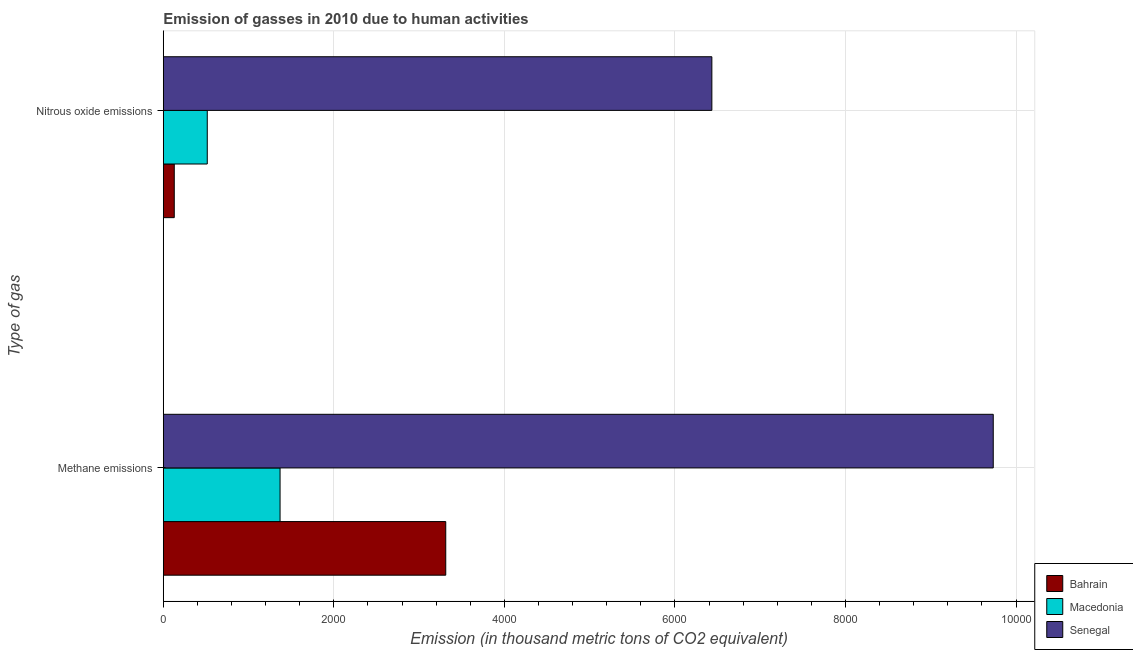How many different coloured bars are there?
Your answer should be compact. 3. How many groups of bars are there?
Your response must be concise. 2. Are the number of bars per tick equal to the number of legend labels?
Make the answer very short. Yes. How many bars are there on the 2nd tick from the bottom?
Provide a succinct answer. 3. What is the label of the 1st group of bars from the top?
Offer a terse response. Nitrous oxide emissions. What is the amount of methane emissions in Bahrain?
Your answer should be compact. 3312.3. Across all countries, what is the maximum amount of methane emissions?
Your answer should be compact. 9732.9. Across all countries, what is the minimum amount of nitrous oxide emissions?
Ensure brevity in your answer.  128.6. In which country was the amount of nitrous oxide emissions maximum?
Offer a terse response. Senegal. In which country was the amount of nitrous oxide emissions minimum?
Offer a very short reply. Bahrain. What is the total amount of methane emissions in the graph?
Offer a very short reply. 1.44e+04. What is the difference between the amount of methane emissions in Senegal and that in Bahrain?
Offer a terse response. 6420.6. What is the difference between the amount of methane emissions in Bahrain and the amount of nitrous oxide emissions in Senegal?
Keep it short and to the point. -3120.7. What is the average amount of nitrous oxide emissions per country?
Offer a very short reply. 2359.07. What is the difference between the amount of nitrous oxide emissions and amount of methane emissions in Bahrain?
Give a very brief answer. -3183.7. What is the ratio of the amount of methane emissions in Macedonia to that in Bahrain?
Give a very brief answer. 0.41. In how many countries, is the amount of nitrous oxide emissions greater than the average amount of nitrous oxide emissions taken over all countries?
Offer a very short reply. 1. What does the 1st bar from the top in Methane emissions represents?
Provide a succinct answer. Senegal. What does the 2nd bar from the bottom in Nitrous oxide emissions represents?
Give a very brief answer. Macedonia. How many countries are there in the graph?
Ensure brevity in your answer.  3. Are the values on the major ticks of X-axis written in scientific E-notation?
Your answer should be very brief. No. Does the graph contain any zero values?
Give a very brief answer. No. Where does the legend appear in the graph?
Your response must be concise. Bottom right. How are the legend labels stacked?
Provide a succinct answer. Vertical. What is the title of the graph?
Offer a very short reply. Emission of gasses in 2010 due to human activities. What is the label or title of the X-axis?
Provide a succinct answer. Emission (in thousand metric tons of CO2 equivalent). What is the label or title of the Y-axis?
Give a very brief answer. Type of gas. What is the Emission (in thousand metric tons of CO2 equivalent) in Bahrain in Methane emissions?
Offer a very short reply. 3312.3. What is the Emission (in thousand metric tons of CO2 equivalent) of Macedonia in Methane emissions?
Give a very brief answer. 1369.3. What is the Emission (in thousand metric tons of CO2 equivalent) of Senegal in Methane emissions?
Your response must be concise. 9732.9. What is the Emission (in thousand metric tons of CO2 equivalent) in Bahrain in Nitrous oxide emissions?
Offer a very short reply. 128.6. What is the Emission (in thousand metric tons of CO2 equivalent) of Macedonia in Nitrous oxide emissions?
Provide a short and direct response. 515.6. What is the Emission (in thousand metric tons of CO2 equivalent) in Senegal in Nitrous oxide emissions?
Offer a very short reply. 6433. Across all Type of gas, what is the maximum Emission (in thousand metric tons of CO2 equivalent) of Bahrain?
Your response must be concise. 3312.3. Across all Type of gas, what is the maximum Emission (in thousand metric tons of CO2 equivalent) in Macedonia?
Give a very brief answer. 1369.3. Across all Type of gas, what is the maximum Emission (in thousand metric tons of CO2 equivalent) in Senegal?
Your response must be concise. 9732.9. Across all Type of gas, what is the minimum Emission (in thousand metric tons of CO2 equivalent) in Bahrain?
Offer a very short reply. 128.6. Across all Type of gas, what is the minimum Emission (in thousand metric tons of CO2 equivalent) in Macedonia?
Your response must be concise. 515.6. Across all Type of gas, what is the minimum Emission (in thousand metric tons of CO2 equivalent) in Senegal?
Give a very brief answer. 6433. What is the total Emission (in thousand metric tons of CO2 equivalent) of Bahrain in the graph?
Give a very brief answer. 3440.9. What is the total Emission (in thousand metric tons of CO2 equivalent) in Macedonia in the graph?
Ensure brevity in your answer.  1884.9. What is the total Emission (in thousand metric tons of CO2 equivalent) of Senegal in the graph?
Ensure brevity in your answer.  1.62e+04. What is the difference between the Emission (in thousand metric tons of CO2 equivalent) in Bahrain in Methane emissions and that in Nitrous oxide emissions?
Give a very brief answer. 3183.7. What is the difference between the Emission (in thousand metric tons of CO2 equivalent) in Macedonia in Methane emissions and that in Nitrous oxide emissions?
Provide a succinct answer. 853.7. What is the difference between the Emission (in thousand metric tons of CO2 equivalent) of Senegal in Methane emissions and that in Nitrous oxide emissions?
Give a very brief answer. 3299.9. What is the difference between the Emission (in thousand metric tons of CO2 equivalent) in Bahrain in Methane emissions and the Emission (in thousand metric tons of CO2 equivalent) in Macedonia in Nitrous oxide emissions?
Provide a succinct answer. 2796.7. What is the difference between the Emission (in thousand metric tons of CO2 equivalent) in Bahrain in Methane emissions and the Emission (in thousand metric tons of CO2 equivalent) in Senegal in Nitrous oxide emissions?
Give a very brief answer. -3120.7. What is the difference between the Emission (in thousand metric tons of CO2 equivalent) of Macedonia in Methane emissions and the Emission (in thousand metric tons of CO2 equivalent) of Senegal in Nitrous oxide emissions?
Provide a short and direct response. -5063.7. What is the average Emission (in thousand metric tons of CO2 equivalent) of Bahrain per Type of gas?
Provide a succinct answer. 1720.45. What is the average Emission (in thousand metric tons of CO2 equivalent) of Macedonia per Type of gas?
Ensure brevity in your answer.  942.45. What is the average Emission (in thousand metric tons of CO2 equivalent) in Senegal per Type of gas?
Your answer should be very brief. 8082.95. What is the difference between the Emission (in thousand metric tons of CO2 equivalent) in Bahrain and Emission (in thousand metric tons of CO2 equivalent) in Macedonia in Methane emissions?
Provide a succinct answer. 1943. What is the difference between the Emission (in thousand metric tons of CO2 equivalent) of Bahrain and Emission (in thousand metric tons of CO2 equivalent) of Senegal in Methane emissions?
Give a very brief answer. -6420.6. What is the difference between the Emission (in thousand metric tons of CO2 equivalent) of Macedonia and Emission (in thousand metric tons of CO2 equivalent) of Senegal in Methane emissions?
Make the answer very short. -8363.6. What is the difference between the Emission (in thousand metric tons of CO2 equivalent) of Bahrain and Emission (in thousand metric tons of CO2 equivalent) of Macedonia in Nitrous oxide emissions?
Your answer should be compact. -387. What is the difference between the Emission (in thousand metric tons of CO2 equivalent) in Bahrain and Emission (in thousand metric tons of CO2 equivalent) in Senegal in Nitrous oxide emissions?
Offer a very short reply. -6304.4. What is the difference between the Emission (in thousand metric tons of CO2 equivalent) in Macedonia and Emission (in thousand metric tons of CO2 equivalent) in Senegal in Nitrous oxide emissions?
Your answer should be compact. -5917.4. What is the ratio of the Emission (in thousand metric tons of CO2 equivalent) of Bahrain in Methane emissions to that in Nitrous oxide emissions?
Your answer should be compact. 25.76. What is the ratio of the Emission (in thousand metric tons of CO2 equivalent) in Macedonia in Methane emissions to that in Nitrous oxide emissions?
Give a very brief answer. 2.66. What is the ratio of the Emission (in thousand metric tons of CO2 equivalent) in Senegal in Methane emissions to that in Nitrous oxide emissions?
Provide a succinct answer. 1.51. What is the difference between the highest and the second highest Emission (in thousand metric tons of CO2 equivalent) in Bahrain?
Give a very brief answer. 3183.7. What is the difference between the highest and the second highest Emission (in thousand metric tons of CO2 equivalent) in Macedonia?
Offer a very short reply. 853.7. What is the difference between the highest and the second highest Emission (in thousand metric tons of CO2 equivalent) in Senegal?
Give a very brief answer. 3299.9. What is the difference between the highest and the lowest Emission (in thousand metric tons of CO2 equivalent) in Bahrain?
Offer a terse response. 3183.7. What is the difference between the highest and the lowest Emission (in thousand metric tons of CO2 equivalent) of Macedonia?
Give a very brief answer. 853.7. What is the difference between the highest and the lowest Emission (in thousand metric tons of CO2 equivalent) in Senegal?
Offer a terse response. 3299.9. 